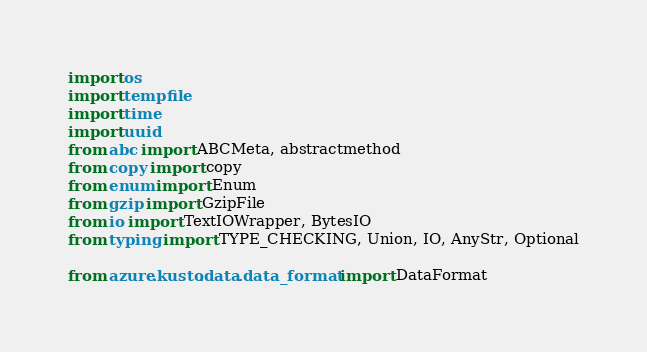<code> <loc_0><loc_0><loc_500><loc_500><_Python_>import os
import tempfile
import time
import uuid
from abc import ABCMeta, abstractmethod
from copy import copy
from enum import Enum
from gzip import GzipFile
from io import TextIOWrapper, BytesIO
from typing import TYPE_CHECKING, Union, IO, AnyStr, Optional

from azure.kusto.data.data_format import DataFormat
</code> 